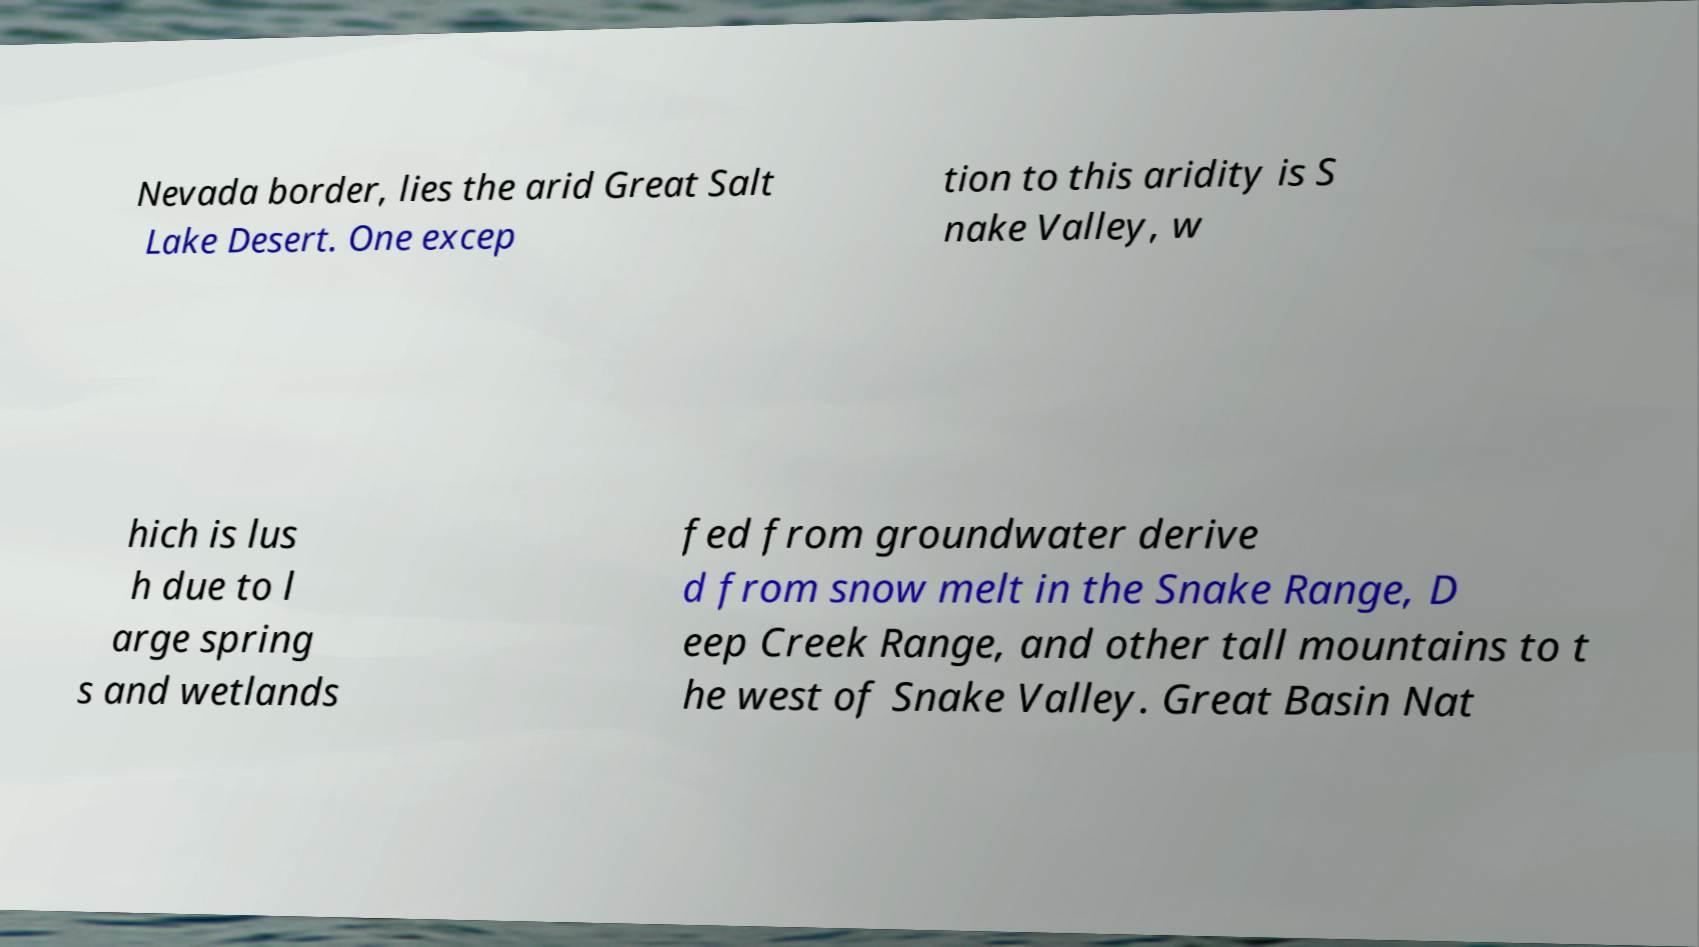For documentation purposes, I need the text within this image transcribed. Could you provide that? Nevada border, lies the arid Great Salt Lake Desert. One excep tion to this aridity is S nake Valley, w hich is lus h due to l arge spring s and wetlands fed from groundwater derive d from snow melt in the Snake Range, D eep Creek Range, and other tall mountains to t he west of Snake Valley. Great Basin Nat 